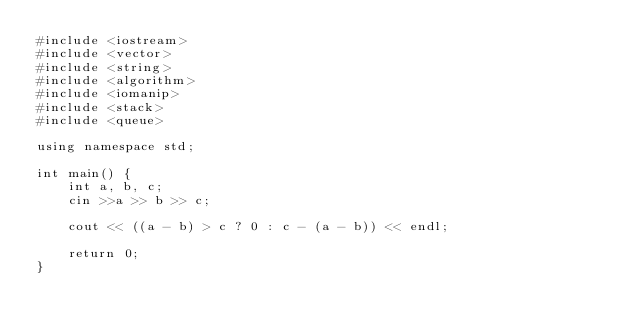Convert code to text. <code><loc_0><loc_0><loc_500><loc_500><_C#_>#include <iostream>
#include <vector>
#include <string>
#include <algorithm>
#include <iomanip>
#include <stack>
#include <queue>

using namespace std;

int main() {
    int a, b, c;
    cin >>a >> b >> c;
    
    cout << ((a - b) > c ? 0 : c - (a - b)) << endl;
    
    return 0;
}
</code> 